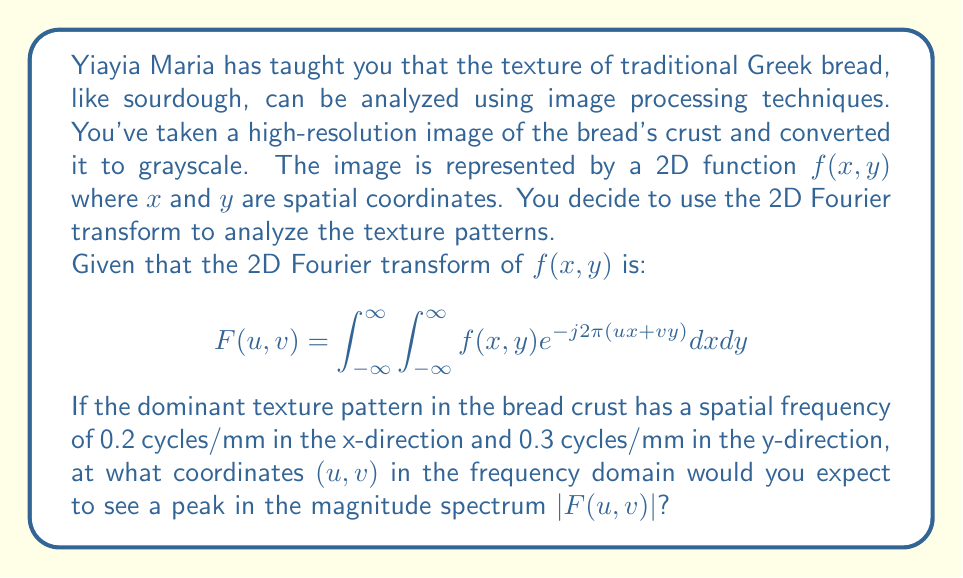Provide a solution to this math problem. To solve this problem, we need to understand the relationship between spatial frequencies and the Fourier transform:

1) In the 2D Fourier transform, the variables $u$ and $v$ represent frequencies in the x and y directions, respectively.

2) The units of $u$ and $v$ are cycles per unit length, which matches our given spatial frequencies.

3) In the Fourier domain, peaks in the magnitude spectrum $|F(u,v)|$ correspond to dominant frequencies in the original image.

4) The spatial frequencies given in the problem directly translate to the coordinates in the frequency domain:
   - 0.2 cycles/mm in x-direction corresponds to $u = 0.2$
   - 0.3 cycles/mm in y-direction corresponds to $v = 0.3$

5) However, due to the properties of the Fourier transform, we expect symmetric peaks. This means we will see peaks at:
   $(u,v) = (0.2, 0.3)$ and $(-0.2, -0.3)$

6) Additionally, because we're dealing with real-valued functions (grayscale image), the Fourier transform will have conjugate symmetry. This means we will also see peaks at:
   $(u,v) = (0.2, -0.3)$ and $(-0.2, 0.3)$

Therefore, we expect to see peaks in the magnitude spectrum $|F(u,v)|$ at four locations: $(0.2, 0.3)$, $(-0.2, -0.3)$, $(0.2, -0.3)$, and $(-0.2, 0.3)$.
Answer: Peaks in $|F(u,v)|$ are expected at $(u,v) = \pm(0.2, 0.3)$ and $\pm(0.2, -0.3)$ cycles/mm. 